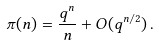Convert formula to latex. <formula><loc_0><loc_0><loc_500><loc_500>\pi ( n ) = \frac { q ^ { n } } { n } + O ( q ^ { n / 2 } ) \, .</formula> 